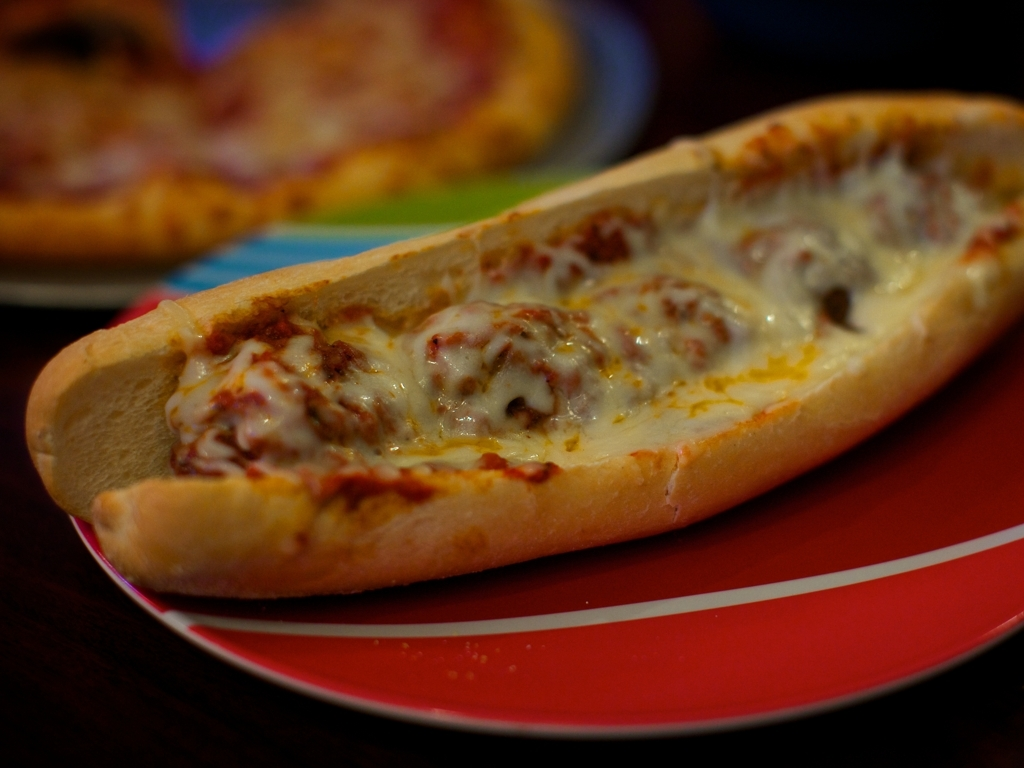Could you suggest some beverages that would pair well with this sandwich? Certainly! A refreshing soda, an iced tea, or even a light beer would pair nicely with the rich and savory flavors of the cheese-covered sub sandwich. 